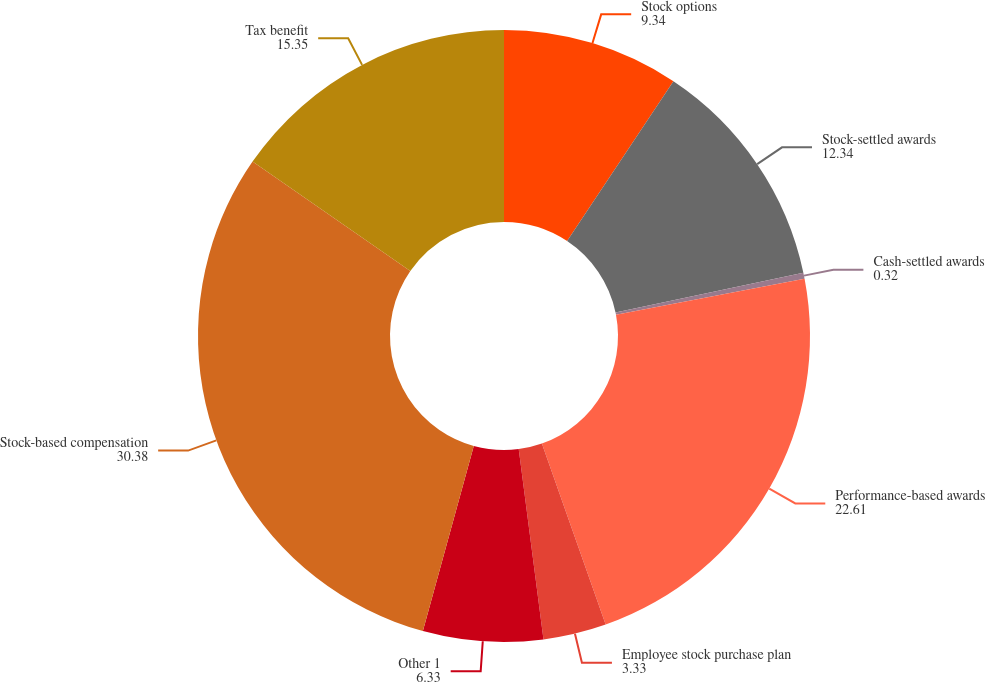Convert chart to OTSL. <chart><loc_0><loc_0><loc_500><loc_500><pie_chart><fcel>Stock options<fcel>Stock-settled awards<fcel>Cash-settled awards<fcel>Performance-based awards<fcel>Employee stock purchase plan<fcel>Other 1<fcel>Stock-based compensation<fcel>Tax benefit<nl><fcel>9.34%<fcel>12.34%<fcel>0.32%<fcel>22.61%<fcel>3.33%<fcel>6.33%<fcel>30.38%<fcel>15.35%<nl></chart> 